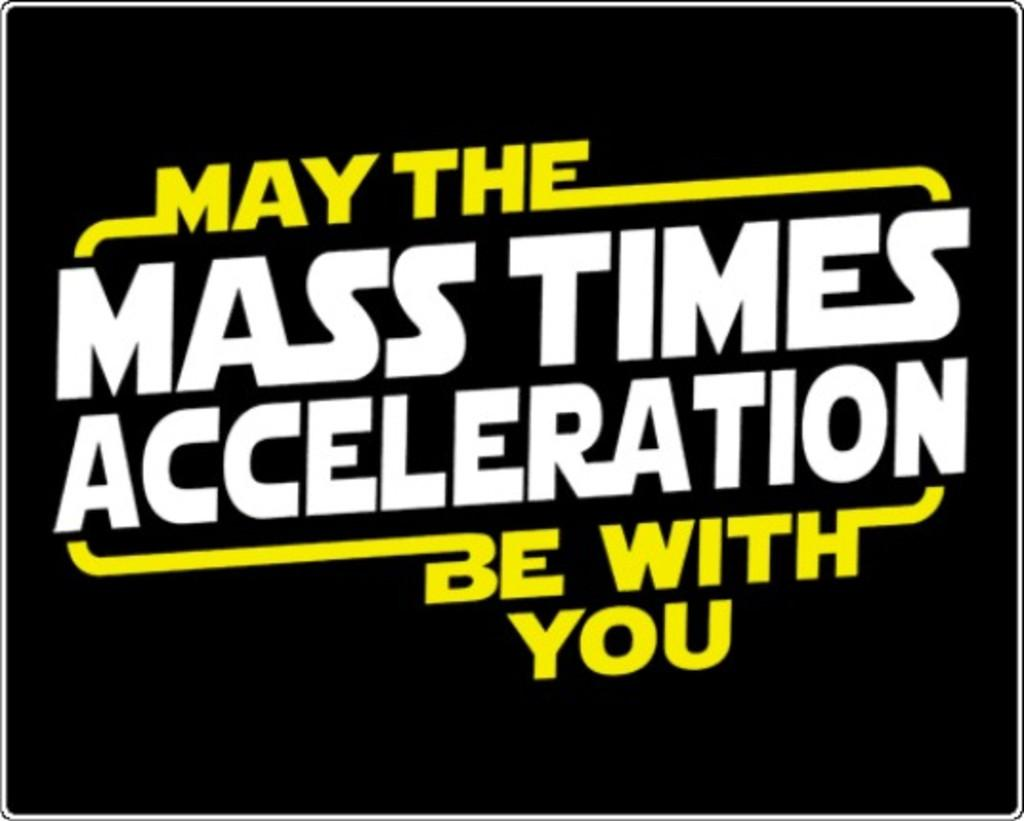What can be found in the image that contains information or words? There is text in the image. What type of stove is depicted in the image? There is no stove present in the image; it only contains text. 